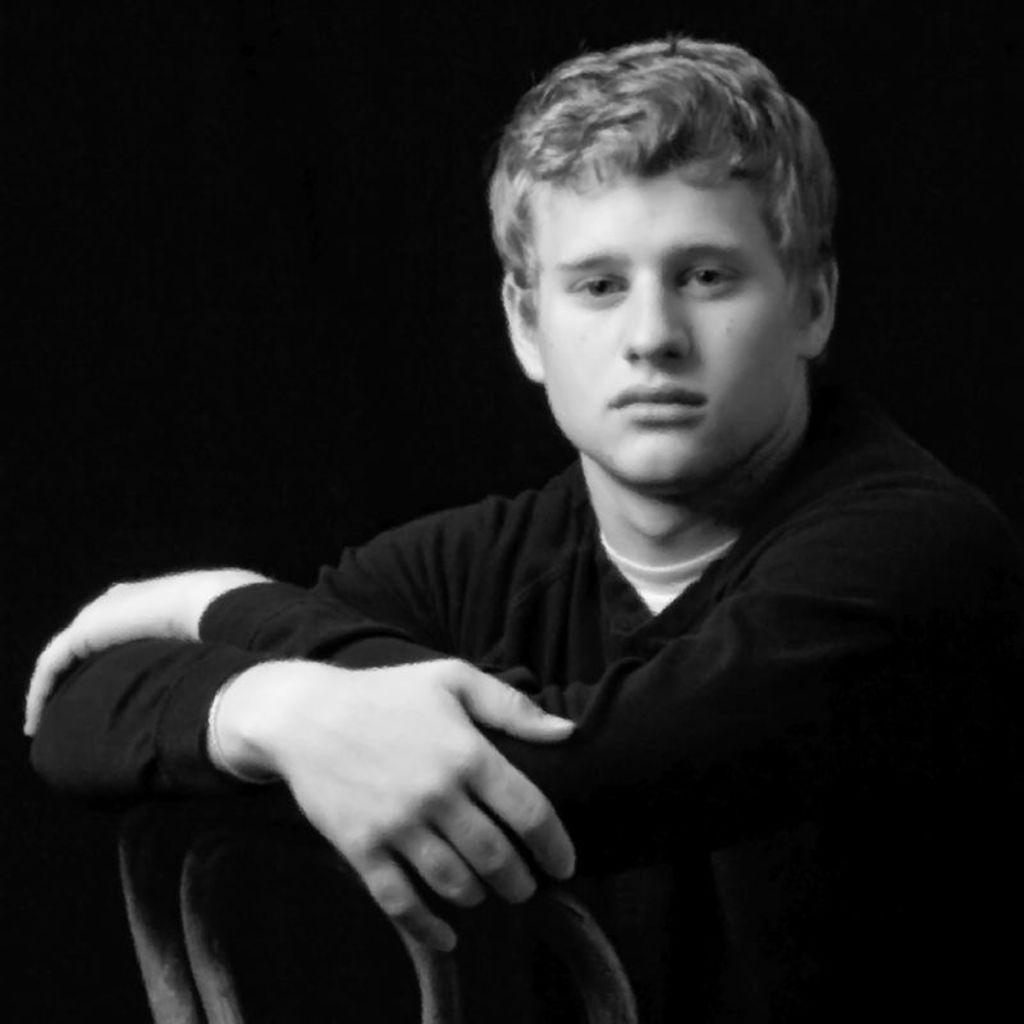What is the main subject of the image? There is a person in the image. What is the person wearing? The person is wearing a black dress. Can you describe the background of the image? The background of the image is dark. What type of order is the judge giving to the giants in the image? There is no judge or giants present in the image, so no such order can be given. 